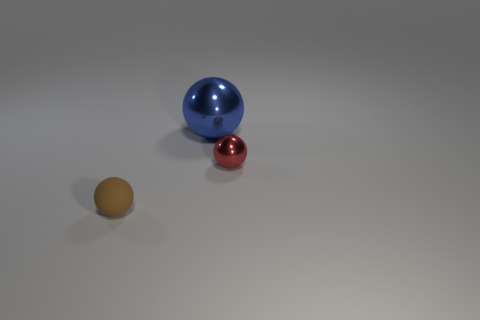Add 1 big blue metal balls. How many objects exist? 4 Subtract all metal spheres. Subtract all matte spheres. How many objects are left? 0 Add 2 small red things. How many small red things are left? 3 Add 3 big cyan matte cylinders. How many big cyan matte cylinders exist? 3 Subtract 1 blue balls. How many objects are left? 2 